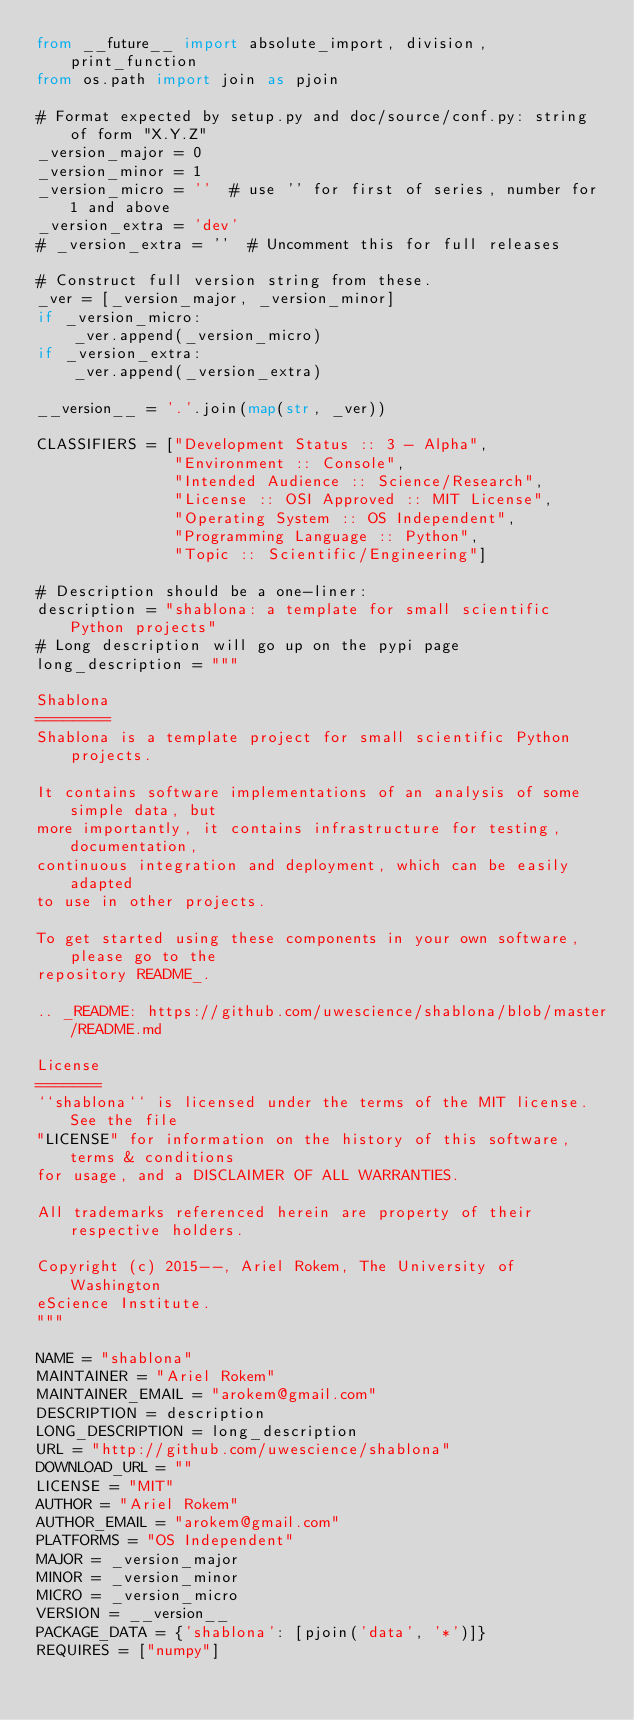Convert code to text. <code><loc_0><loc_0><loc_500><loc_500><_Python_>from __future__ import absolute_import, division, print_function
from os.path import join as pjoin

# Format expected by setup.py and doc/source/conf.py: string of form "X.Y.Z"
_version_major = 0
_version_minor = 1
_version_micro = ''  # use '' for first of series, number for 1 and above
_version_extra = 'dev'
# _version_extra = ''  # Uncomment this for full releases

# Construct full version string from these.
_ver = [_version_major, _version_minor]
if _version_micro:
    _ver.append(_version_micro)
if _version_extra:
    _ver.append(_version_extra)

__version__ = '.'.join(map(str, _ver))

CLASSIFIERS = ["Development Status :: 3 - Alpha",
               "Environment :: Console",
               "Intended Audience :: Science/Research",
               "License :: OSI Approved :: MIT License",
               "Operating System :: OS Independent",
               "Programming Language :: Python",
               "Topic :: Scientific/Engineering"]

# Description should be a one-liner:
description = "shablona: a template for small scientific Python projects"
# Long description will go up on the pypi page
long_description = """

Shablona
========
Shablona is a template project for small scientific Python projects.

It contains software implementations of an analysis of some simple data, but
more importantly, it contains infrastructure for testing, documentation,
continuous integration and deployment, which can be easily adapted
to use in other projects.

To get started using these components in your own software, please go to the
repository README_.

.. _README: https://github.com/uwescience/shablona/blob/master/README.md

License
=======
``shablona`` is licensed under the terms of the MIT license. See the file
"LICENSE" for information on the history of this software, terms & conditions
for usage, and a DISCLAIMER OF ALL WARRANTIES.

All trademarks referenced herein are property of their respective holders.

Copyright (c) 2015--, Ariel Rokem, The University of Washington
eScience Institute.
"""

NAME = "shablona"
MAINTAINER = "Ariel Rokem"
MAINTAINER_EMAIL = "arokem@gmail.com"
DESCRIPTION = description
LONG_DESCRIPTION = long_description
URL = "http://github.com/uwescience/shablona"
DOWNLOAD_URL = ""
LICENSE = "MIT"
AUTHOR = "Ariel Rokem"
AUTHOR_EMAIL = "arokem@gmail.com"
PLATFORMS = "OS Independent"
MAJOR = _version_major
MINOR = _version_minor
MICRO = _version_micro
VERSION = __version__
PACKAGE_DATA = {'shablona': [pjoin('data', '*')]}
REQUIRES = ["numpy"]
</code> 